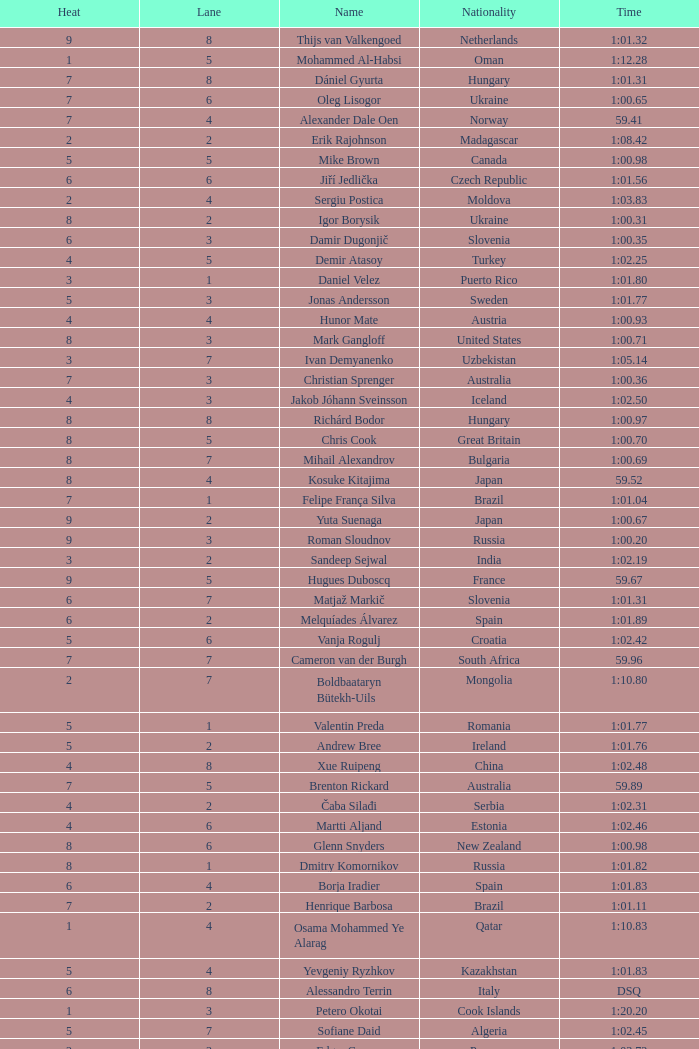What is the smallest lane number of Xue Ruipeng? 8.0. 